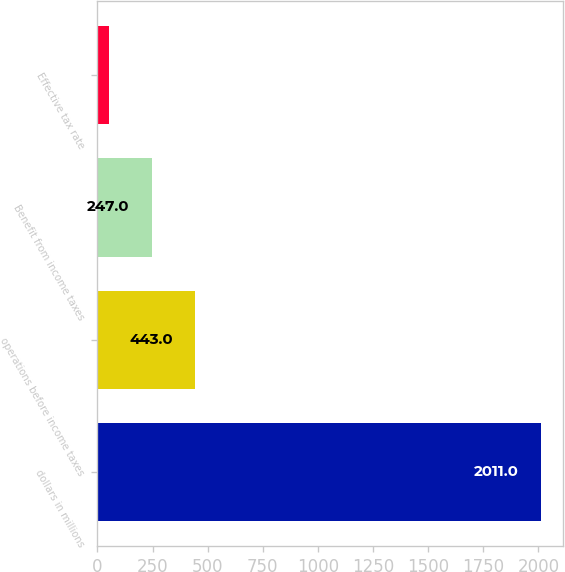Convert chart. <chart><loc_0><loc_0><loc_500><loc_500><bar_chart><fcel>dollars in millions<fcel>operations before income taxes<fcel>Benefit from income taxes<fcel>Effective tax rate<nl><fcel>2011<fcel>443<fcel>247<fcel>51<nl></chart> 